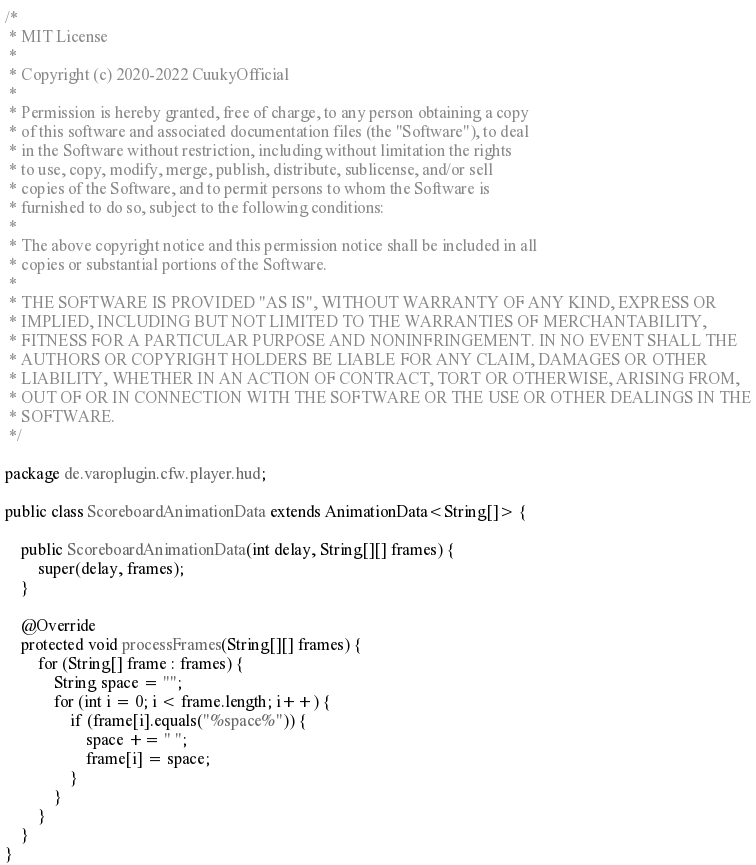Convert code to text. <code><loc_0><loc_0><loc_500><loc_500><_Java_>/*
 * MIT License
 * 
 * Copyright (c) 2020-2022 CuukyOfficial
 * 
 * Permission is hereby granted, free of charge, to any person obtaining a copy
 * of this software and associated documentation files (the "Software"), to deal
 * in the Software without restriction, including without limitation the rights
 * to use, copy, modify, merge, publish, distribute, sublicense, and/or sell
 * copies of the Software, and to permit persons to whom the Software is
 * furnished to do so, subject to the following conditions:
 * 
 * The above copyright notice and this permission notice shall be included in all
 * copies or substantial portions of the Software.
 * 
 * THE SOFTWARE IS PROVIDED "AS IS", WITHOUT WARRANTY OF ANY KIND, EXPRESS OR
 * IMPLIED, INCLUDING BUT NOT LIMITED TO THE WARRANTIES OF MERCHANTABILITY,
 * FITNESS FOR A PARTICULAR PURPOSE AND NONINFRINGEMENT. IN NO EVENT SHALL THE
 * AUTHORS OR COPYRIGHT HOLDERS BE LIABLE FOR ANY CLAIM, DAMAGES OR OTHER
 * LIABILITY, WHETHER IN AN ACTION OF CONTRACT, TORT OR OTHERWISE, ARISING FROM,
 * OUT OF OR IN CONNECTION WITH THE SOFTWARE OR THE USE OR OTHER DEALINGS IN THE
 * SOFTWARE.
 */

package de.varoplugin.cfw.player.hud;

public class ScoreboardAnimationData extends AnimationData<String[]> {

    public ScoreboardAnimationData(int delay, String[][] frames) {
        super(delay, frames);
    }

    @Override
    protected void processFrames(String[][] frames) {
        for (String[] frame : frames) {
            String space = "";
            for (int i = 0; i < frame.length; i++) {
                if (frame[i].equals("%space%")) {
                    space += " ";
                    frame[i] = space;
                }
            }
        }
    }
}
</code> 